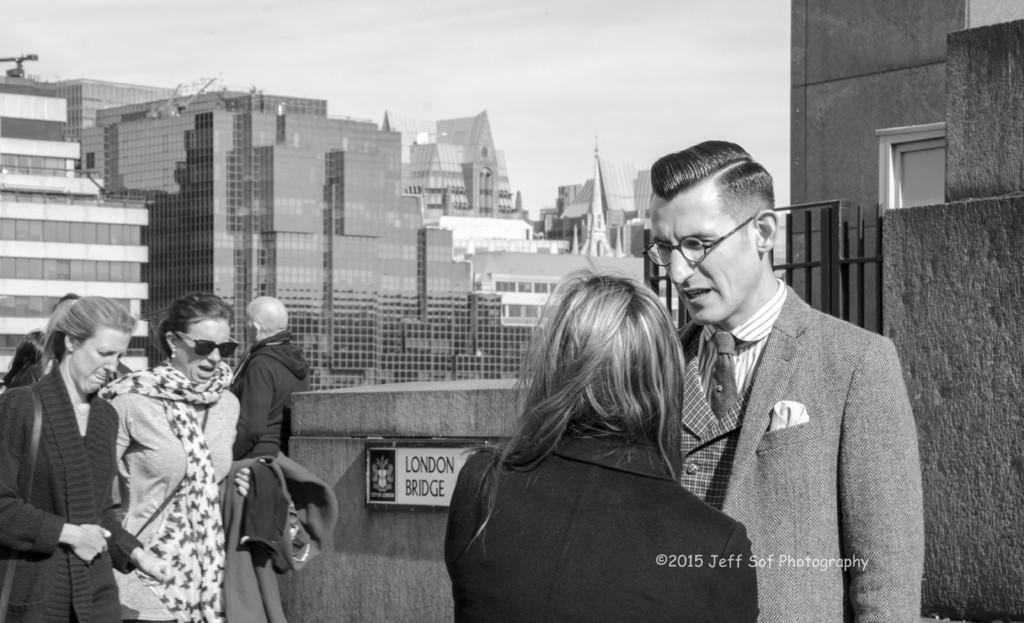Could you give a brief overview of what you see in this image? This is a black and white picture. In the foreground of the picture there are people standing, behind them there is a wall and gate. On the right there is a window. In the center of the background there are buildings. Sky is clear and it is sunny. 